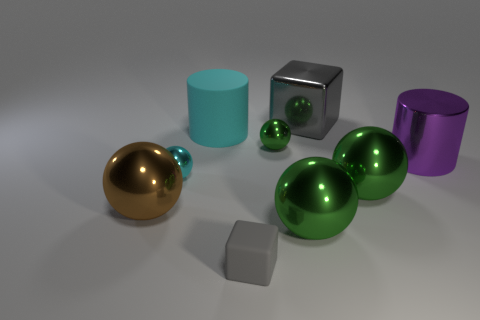How many green spheres must be subtracted to get 1 green spheres? 2 Subtract all yellow blocks. How many green spheres are left? 3 Subtract all brown balls. How many balls are left? 4 Subtract all big brown metal spheres. How many spheres are left? 4 Subtract 1 spheres. How many spheres are left? 4 Subtract all blue spheres. Subtract all red blocks. How many spheres are left? 5 Add 1 big balls. How many objects exist? 10 Subtract all blocks. How many objects are left? 7 Subtract all big brown things. Subtract all cyan balls. How many objects are left? 7 Add 4 small cyan metallic spheres. How many small cyan metallic spheres are left? 5 